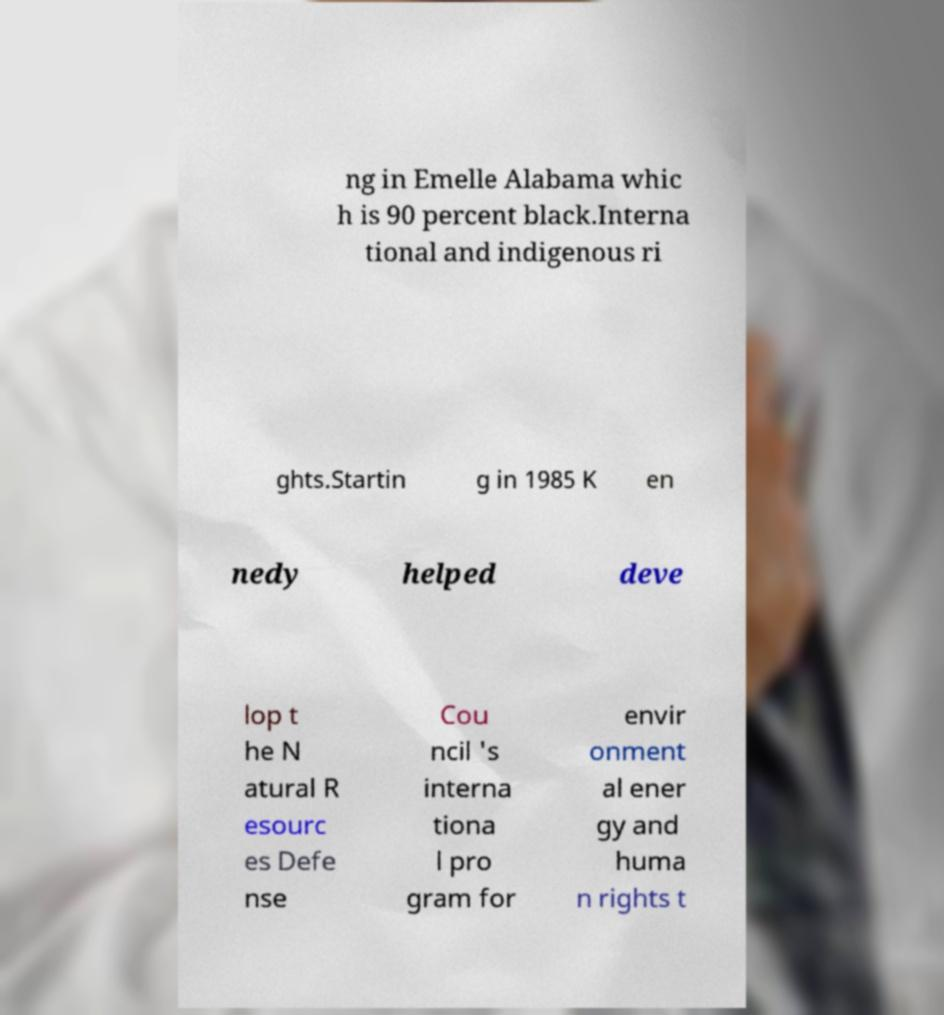Could you extract and type out the text from this image? ng in Emelle Alabama whic h is 90 percent black.Interna tional and indigenous ri ghts.Startin g in 1985 K en nedy helped deve lop t he N atural R esourc es Defe nse Cou ncil 's interna tiona l pro gram for envir onment al ener gy and huma n rights t 